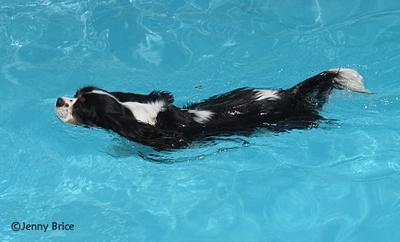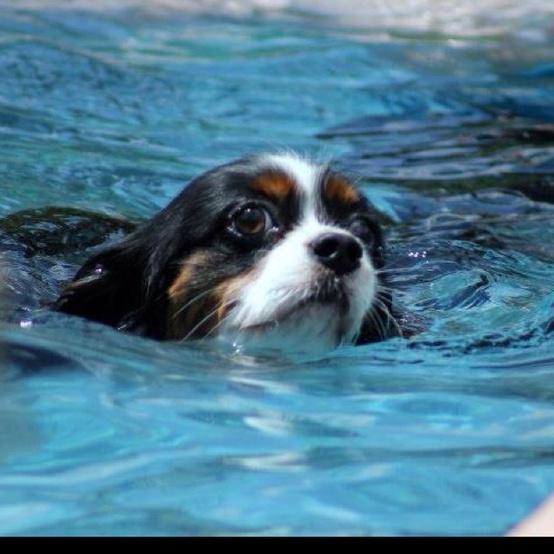The first image is the image on the left, the second image is the image on the right. For the images displayed, is the sentence "Left image shows a dog swimming leftward." factually correct? Answer yes or no. Yes. 